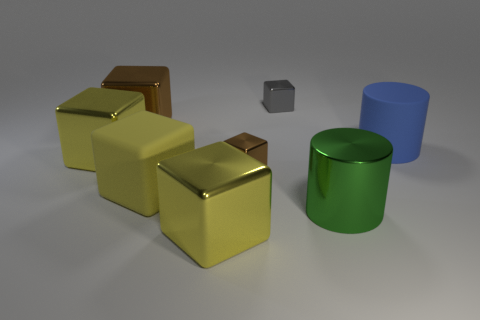Subtract all blue cylinders. How many yellow cubes are left? 3 Subtract all gray blocks. How many blocks are left? 5 Subtract all tiny brown cubes. How many cubes are left? 5 Subtract all green blocks. Subtract all yellow spheres. How many blocks are left? 6 Add 1 small blocks. How many objects exist? 9 Subtract all blocks. How many objects are left? 2 Add 7 tiny brown metal cubes. How many tiny brown metal cubes are left? 8 Add 5 small red cylinders. How many small red cylinders exist? 5 Subtract 0 brown balls. How many objects are left? 8 Subtract all large yellow matte cubes. Subtract all big yellow matte blocks. How many objects are left? 6 